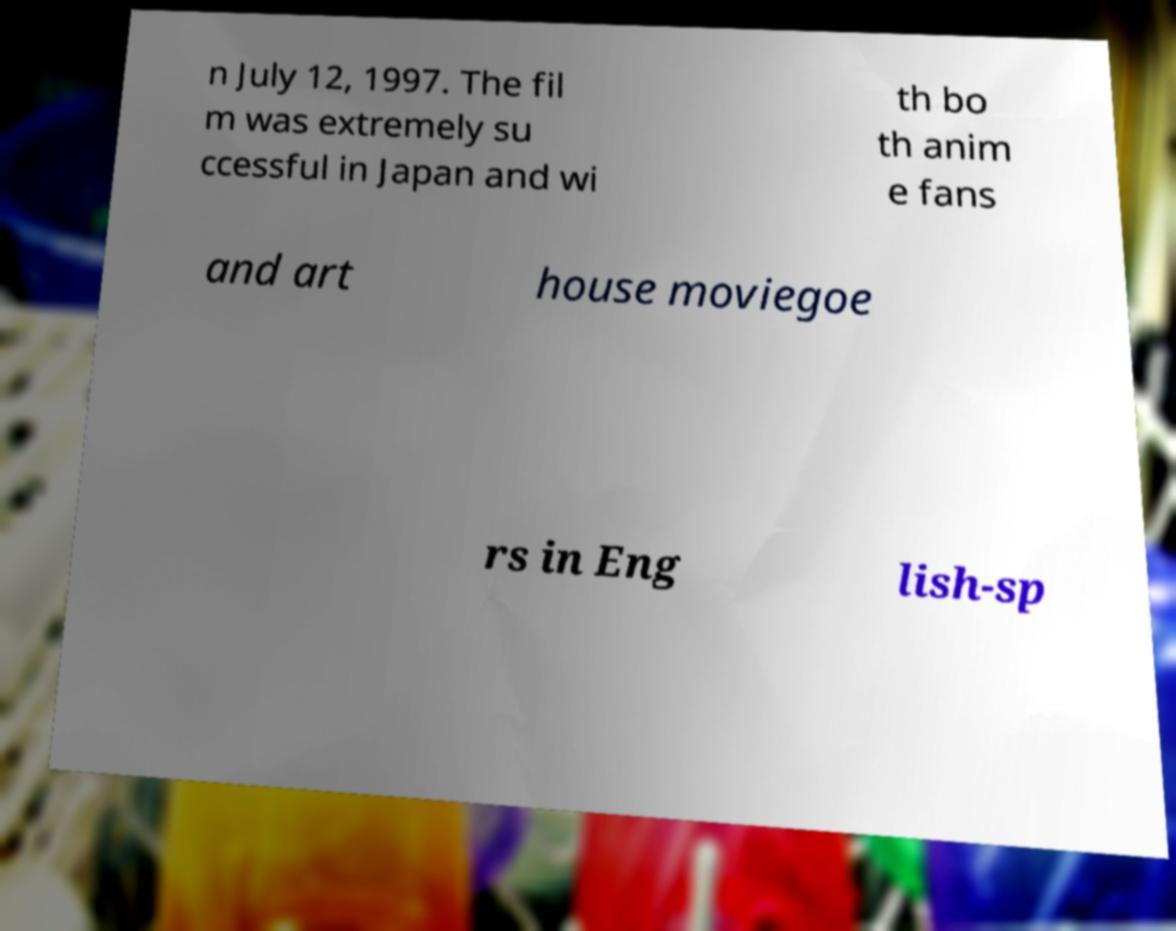There's text embedded in this image that I need extracted. Can you transcribe it verbatim? n July 12, 1997. The fil m was extremely su ccessful in Japan and wi th bo th anim e fans and art house moviegoe rs in Eng lish-sp 